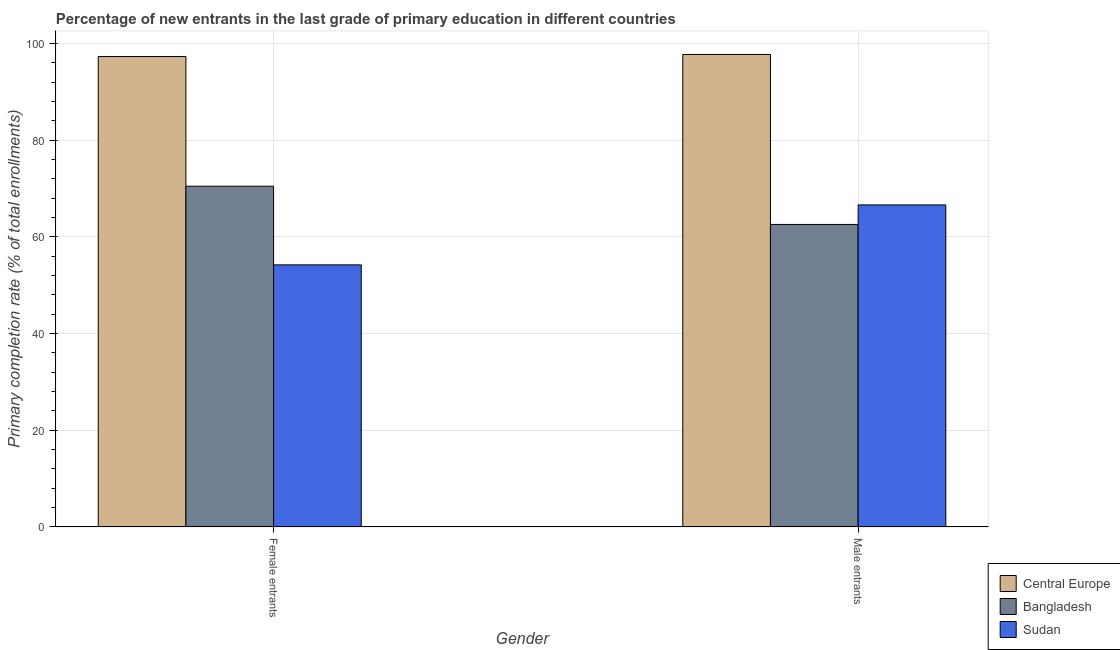How many different coloured bars are there?
Provide a succinct answer. 3. How many groups of bars are there?
Provide a short and direct response. 2. Are the number of bars per tick equal to the number of legend labels?
Offer a very short reply. Yes. How many bars are there on the 2nd tick from the left?
Provide a short and direct response. 3. What is the label of the 1st group of bars from the left?
Your response must be concise. Female entrants. What is the primary completion rate of male entrants in Sudan?
Your answer should be very brief. 66.63. Across all countries, what is the maximum primary completion rate of male entrants?
Provide a short and direct response. 97.76. Across all countries, what is the minimum primary completion rate of male entrants?
Offer a very short reply. 62.59. In which country was the primary completion rate of female entrants maximum?
Keep it short and to the point. Central Europe. In which country was the primary completion rate of female entrants minimum?
Provide a succinct answer. Sudan. What is the total primary completion rate of female entrants in the graph?
Provide a succinct answer. 222.05. What is the difference between the primary completion rate of male entrants in Sudan and that in Bangladesh?
Give a very brief answer. 4.04. What is the difference between the primary completion rate of female entrants in Central Europe and the primary completion rate of male entrants in Bangladesh?
Offer a terse response. 34.73. What is the average primary completion rate of male entrants per country?
Offer a terse response. 75.66. What is the difference between the primary completion rate of male entrants and primary completion rate of female entrants in Bangladesh?
Give a very brief answer. -7.91. In how many countries, is the primary completion rate of male entrants greater than 96 %?
Your response must be concise. 1. What is the ratio of the primary completion rate of male entrants in Bangladesh to that in Sudan?
Keep it short and to the point. 0.94. In how many countries, is the primary completion rate of female entrants greater than the average primary completion rate of female entrants taken over all countries?
Your answer should be very brief. 1. What does the 3rd bar from the left in Male entrants represents?
Your answer should be very brief. Sudan. What does the 2nd bar from the right in Male entrants represents?
Your answer should be compact. Bangladesh. How many bars are there?
Offer a very short reply. 6. What is the difference between two consecutive major ticks on the Y-axis?
Offer a terse response. 20. Does the graph contain grids?
Give a very brief answer. Yes. Where does the legend appear in the graph?
Give a very brief answer. Bottom right. How many legend labels are there?
Your answer should be very brief. 3. How are the legend labels stacked?
Keep it short and to the point. Vertical. What is the title of the graph?
Keep it short and to the point. Percentage of new entrants in the last grade of primary education in different countries. Does "Burkina Faso" appear as one of the legend labels in the graph?
Make the answer very short. No. What is the label or title of the X-axis?
Your answer should be compact. Gender. What is the label or title of the Y-axis?
Keep it short and to the point. Primary completion rate (% of total enrollments). What is the Primary completion rate (% of total enrollments) of Central Europe in Female entrants?
Keep it short and to the point. 97.32. What is the Primary completion rate (% of total enrollments) in Bangladesh in Female entrants?
Provide a short and direct response. 70.5. What is the Primary completion rate (% of total enrollments) in Sudan in Female entrants?
Offer a terse response. 54.23. What is the Primary completion rate (% of total enrollments) in Central Europe in Male entrants?
Make the answer very short. 97.76. What is the Primary completion rate (% of total enrollments) of Bangladesh in Male entrants?
Give a very brief answer. 62.59. What is the Primary completion rate (% of total enrollments) in Sudan in Male entrants?
Your response must be concise. 66.63. Across all Gender, what is the maximum Primary completion rate (% of total enrollments) of Central Europe?
Offer a terse response. 97.76. Across all Gender, what is the maximum Primary completion rate (% of total enrollments) in Bangladesh?
Provide a succinct answer. 70.5. Across all Gender, what is the maximum Primary completion rate (% of total enrollments) in Sudan?
Provide a succinct answer. 66.63. Across all Gender, what is the minimum Primary completion rate (% of total enrollments) in Central Europe?
Offer a very short reply. 97.32. Across all Gender, what is the minimum Primary completion rate (% of total enrollments) in Bangladesh?
Your response must be concise. 62.59. Across all Gender, what is the minimum Primary completion rate (% of total enrollments) in Sudan?
Keep it short and to the point. 54.23. What is the total Primary completion rate (% of total enrollments) in Central Europe in the graph?
Make the answer very short. 195.08. What is the total Primary completion rate (% of total enrollments) of Bangladesh in the graph?
Keep it short and to the point. 133.09. What is the total Primary completion rate (% of total enrollments) of Sudan in the graph?
Provide a short and direct response. 120.86. What is the difference between the Primary completion rate (% of total enrollments) of Central Europe in Female entrants and that in Male entrants?
Make the answer very short. -0.43. What is the difference between the Primary completion rate (% of total enrollments) in Bangladesh in Female entrants and that in Male entrants?
Your answer should be compact. 7.91. What is the difference between the Primary completion rate (% of total enrollments) of Sudan in Female entrants and that in Male entrants?
Your response must be concise. -12.41. What is the difference between the Primary completion rate (% of total enrollments) of Central Europe in Female entrants and the Primary completion rate (% of total enrollments) of Bangladesh in Male entrants?
Offer a very short reply. 34.73. What is the difference between the Primary completion rate (% of total enrollments) in Central Europe in Female entrants and the Primary completion rate (% of total enrollments) in Sudan in Male entrants?
Provide a short and direct response. 30.69. What is the difference between the Primary completion rate (% of total enrollments) in Bangladesh in Female entrants and the Primary completion rate (% of total enrollments) in Sudan in Male entrants?
Provide a short and direct response. 3.87. What is the average Primary completion rate (% of total enrollments) of Central Europe per Gender?
Give a very brief answer. 97.54. What is the average Primary completion rate (% of total enrollments) in Bangladesh per Gender?
Your answer should be compact. 66.54. What is the average Primary completion rate (% of total enrollments) of Sudan per Gender?
Offer a terse response. 60.43. What is the difference between the Primary completion rate (% of total enrollments) of Central Europe and Primary completion rate (% of total enrollments) of Bangladesh in Female entrants?
Keep it short and to the point. 26.82. What is the difference between the Primary completion rate (% of total enrollments) in Central Europe and Primary completion rate (% of total enrollments) in Sudan in Female entrants?
Make the answer very short. 43.1. What is the difference between the Primary completion rate (% of total enrollments) in Bangladesh and Primary completion rate (% of total enrollments) in Sudan in Female entrants?
Offer a terse response. 16.27. What is the difference between the Primary completion rate (% of total enrollments) of Central Europe and Primary completion rate (% of total enrollments) of Bangladesh in Male entrants?
Ensure brevity in your answer.  35.17. What is the difference between the Primary completion rate (% of total enrollments) of Central Europe and Primary completion rate (% of total enrollments) of Sudan in Male entrants?
Provide a succinct answer. 31.12. What is the difference between the Primary completion rate (% of total enrollments) of Bangladesh and Primary completion rate (% of total enrollments) of Sudan in Male entrants?
Offer a very short reply. -4.04. What is the ratio of the Primary completion rate (% of total enrollments) in Central Europe in Female entrants to that in Male entrants?
Your answer should be compact. 1. What is the ratio of the Primary completion rate (% of total enrollments) in Bangladesh in Female entrants to that in Male entrants?
Your answer should be very brief. 1.13. What is the ratio of the Primary completion rate (% of total enrollments) in Sudan in Female entrants to that in Male entrants?
Provide a succinct answer. 0.81. What is the difference between the highest and the second highest Primary completion rate (% of total enrollments) of Central Europe?
Offer a terse response. 0.43. What is the difference between the highest and the second highest Primary completion rate (% of total enrollments) of Bangladesh?
Your answer should be very brief. 7.91. What is the difference between the highest and the second highest Primary completion rate (% of total enrollments) of Sudan?
Offer a very short reply. 12.41. What is the difference between the highest and the lowest Primary completion rate (% of total enrollments) of Central Europe?
Your response must be concise. 0.43. What is the difference between the highest and the lowest Primary completion rate (% of total enrollments) in Bangladesh?
Give a very brief answer. 7.91. What is the difference between the highest and the lowest Primary completion rate (% of total enrollments) of Sudan?
Give a very brief answer. 12.41. 